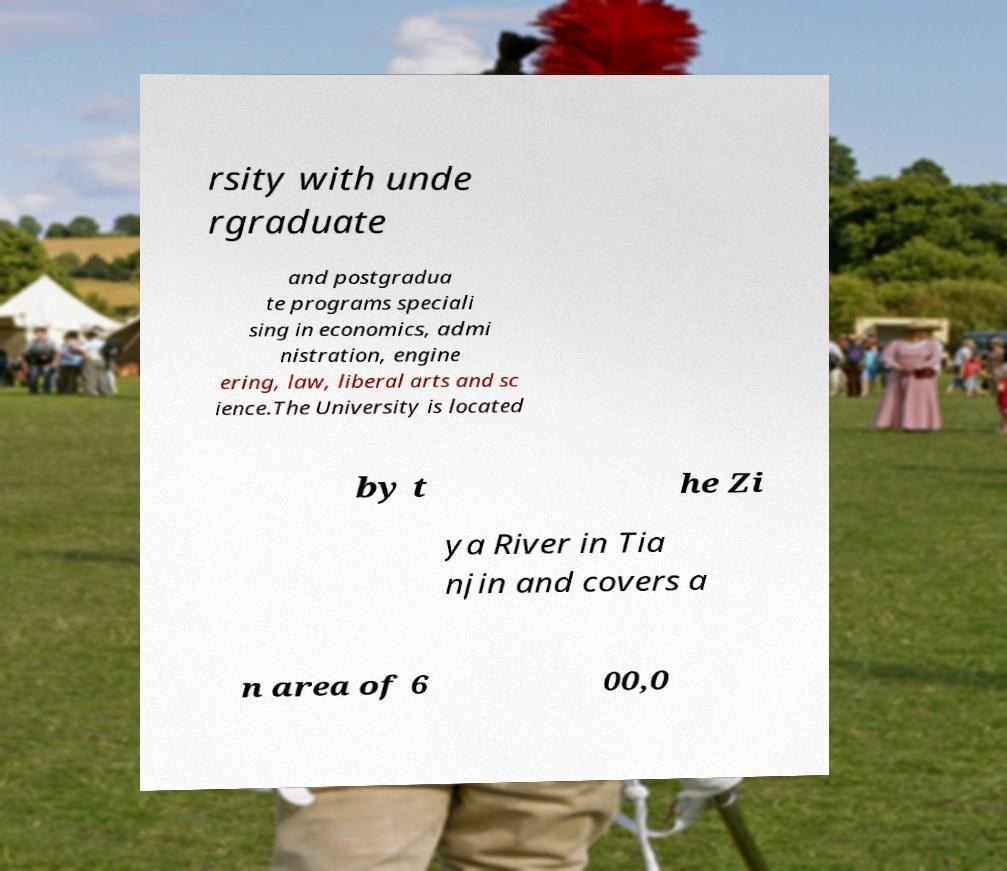I need the written content from this picture converted into text. Can you do that? rsity with unde rgraduate and postgradua te programs speciali sing in economics, admi nistration, engine ering, law, liberal arts and sc ience.The University is located by t he Zi ya River in Tia njin and covers a n area of 6 00,0 